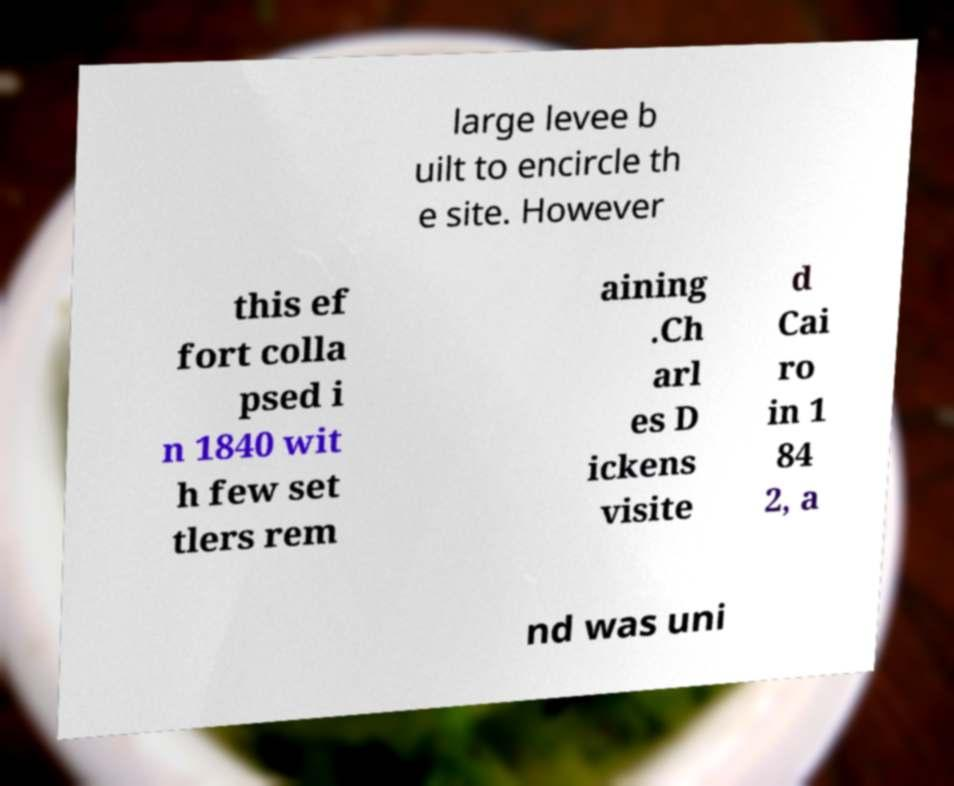I need the written content from this picture converted into text. Can you do that? large levee b uilt to encircle th e site. However this ef fort colla psed i n 1840 wit h few set tlers rem aining .Ch arl es D ickens visite d Cai ro in 1 84 2, a nd was uni 